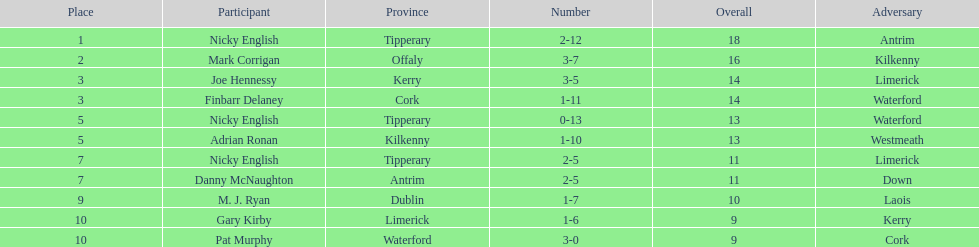How many people are on the list? 9. 